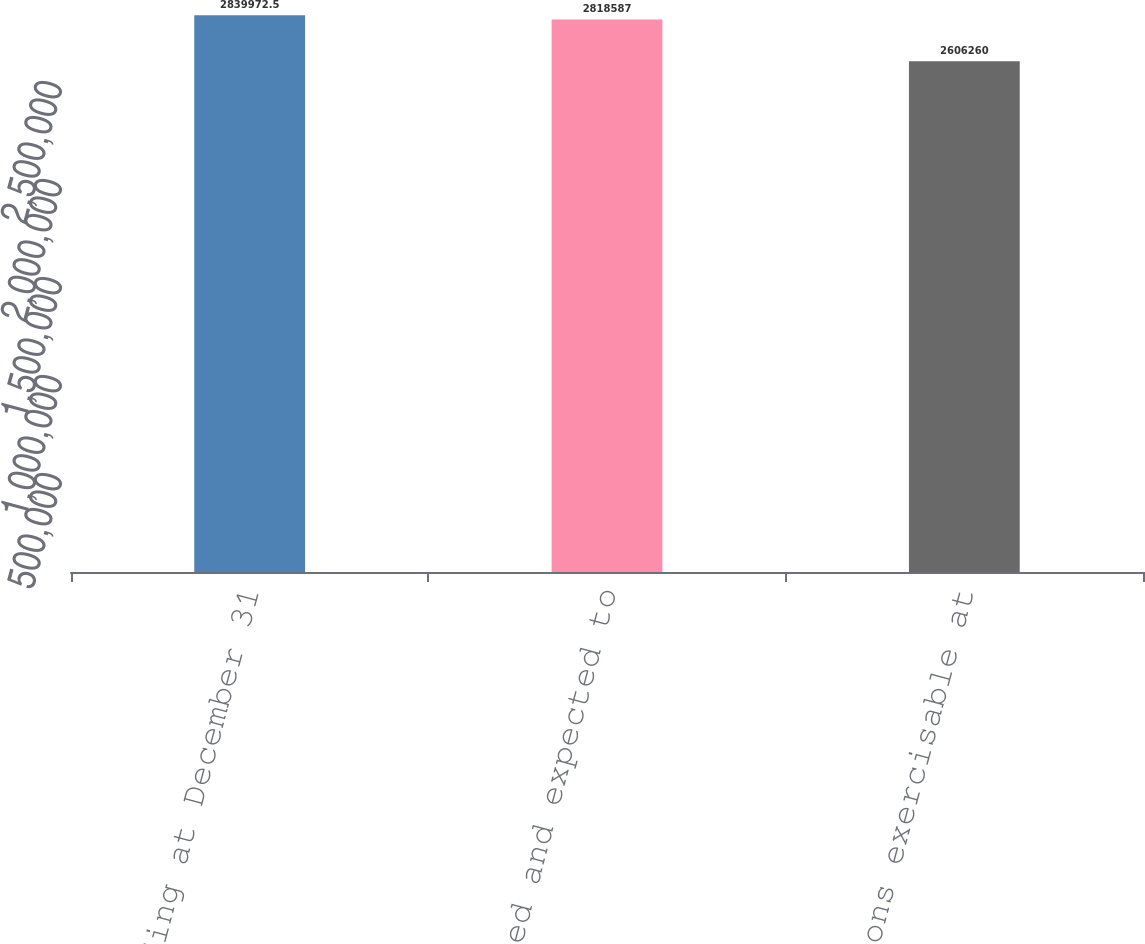Convert chart. <chart><loc_0><loc_0><loc_500><loc_500><bar_chart><fcel>Outstanding at December 31<fcel>Options vested and expected to<fcel>Options exercisable at<nl><fcel>2.83997e+06<fcel>2.81859e+06<fcel>2.60626e+06<nl></chart> 